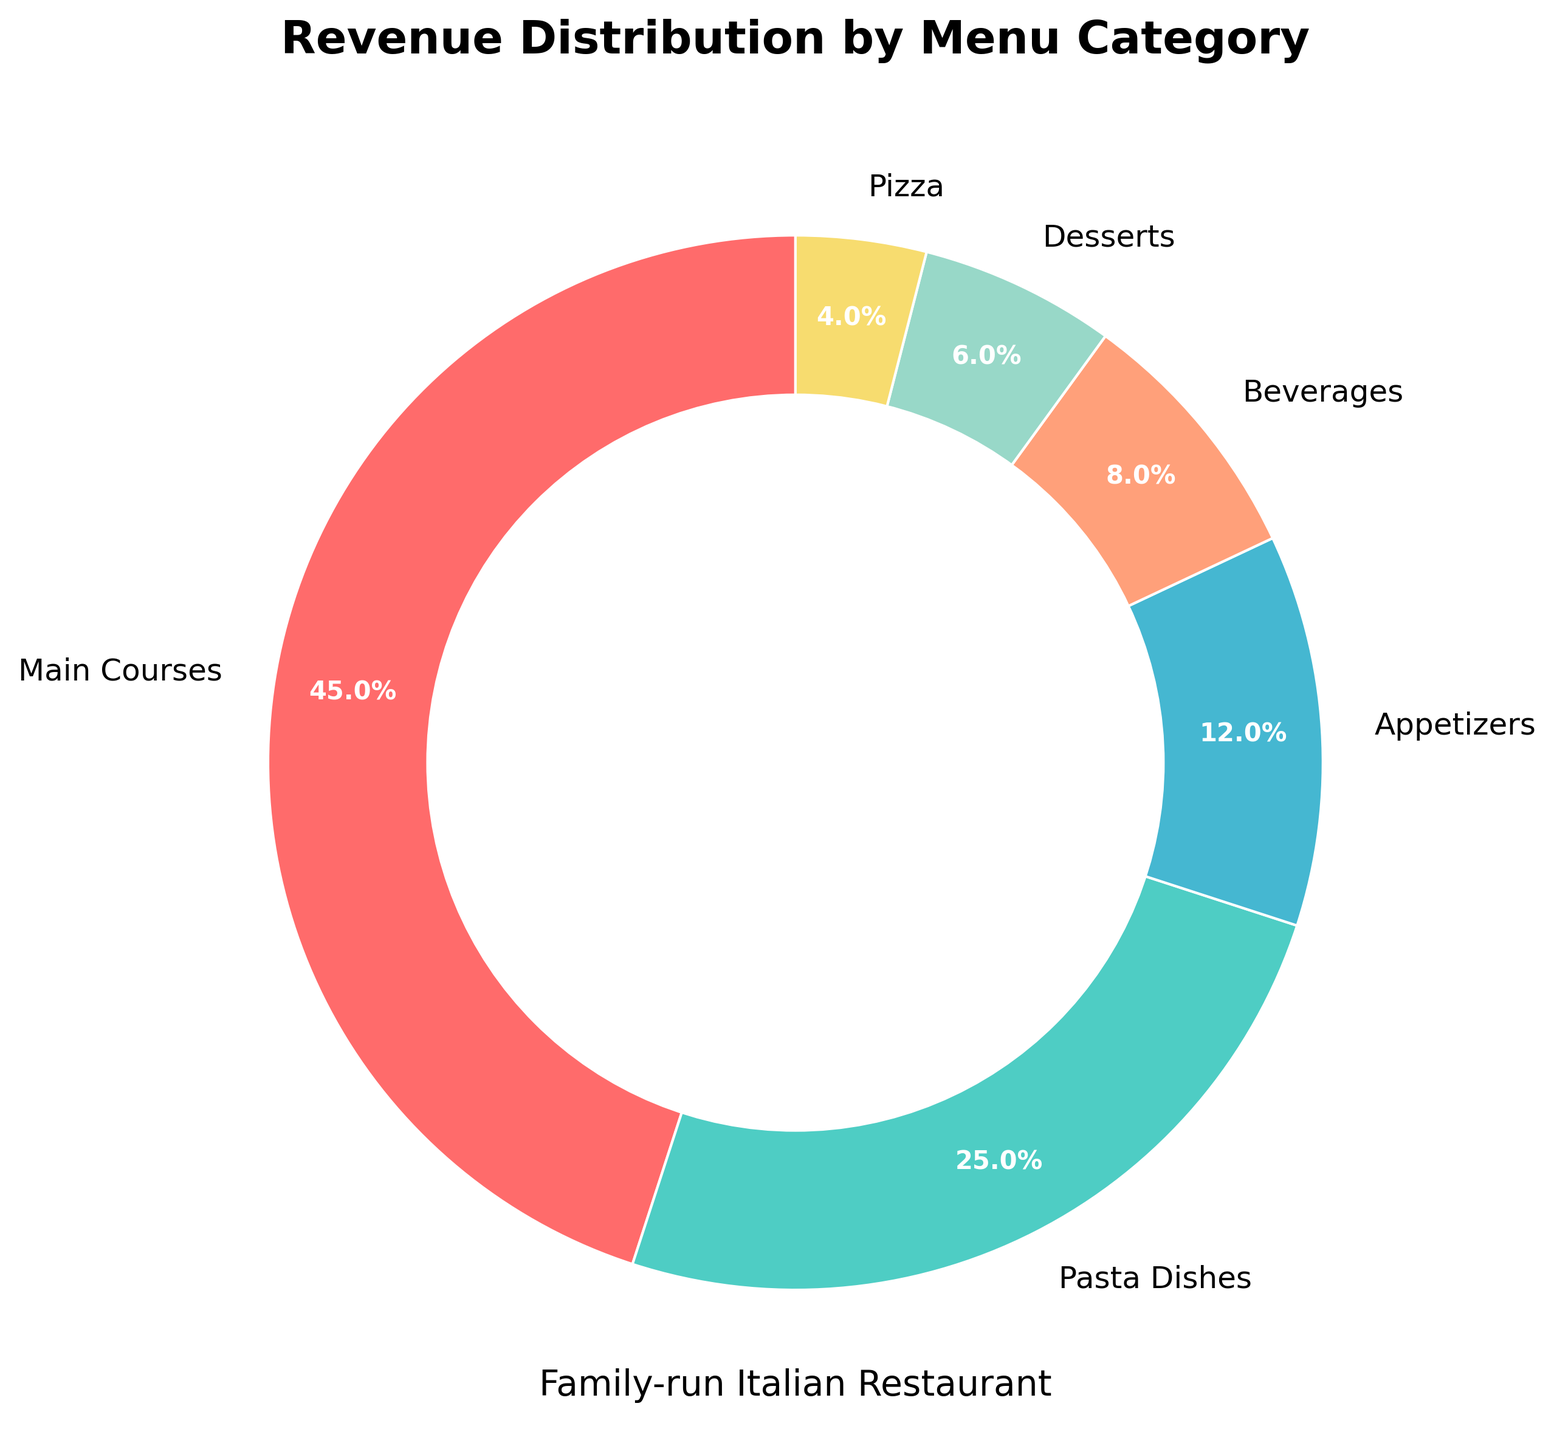Which category contributes the most to the restaurant's revenue? The largest slice in the pie chart represents the "Main Courses" category at 45%, which is the highest percentage.
Answer: Main Courses Which two categories contribute the least to the restaurant's revenue? The smallest slices in the pie chart represent "Pizza" and "Desserts" at 4% and 6%, respectively, making them the categories with the least contribution.
Answer: Pizza and Desserts What is the combined revenue percentage for Pasta Dishes and Beverages? To find the combined percentage, sum up the values for Pasta Dishes (25%) and Beverages (8%): 25% + 8% = 33%.
Answer: 33% Is the revenue from Main Courses more than double the revenue from Desserts? The percentage for Main Courses is 45% and for Desserts is 6%. Calculating double of Desserts gives 6% * 2 = 12%, which is indeed less than 45%.
Answer: Yes What color represents the Appetizers category? The color corresponding to the "Appetizers" label on the pie chart is matched to a specific visual slice, which is a bluish-green shade.
Answer: Bluish-green Is the sum of the revenue percentages of Appetizers and Desserts greater than the revenue from Pasta Dishes? Summing up the percentages for Appetizers (12%) and Desserts (6%) gives 12% + 6% = 18%, which is less than the 25% for Pasta Dishes.
Answer: No How much is the revenue difference between the categories of Beverages and Pizza? Subtracting the percentage for Pizza from the percentage for Beverages: 8% - 4% gives us the difference.
Answer: 4% Are there more categories contributing less than 10% each or more than 10% each? By observing the chart, count the categories with less than 10%: Beverages (8%), Desserts (6%), and Pizza (4%) — 3 categories. Count the more-than-10% categories: Main Courses (45%), Pasta Dishes (25%), Appetizers (12%) — 3 categories.
Answer: Equal What is the second largest revenue category? The pie chart shows that the second largest slice after Main Courses (45%) is for Pasta Dishes (25%).
Answer: Pasta Dishes Compare the percentage contribution of Beverages and Desserts visually and state which is larger. The pie chart slice for Beverages is larger than that for Desserts, with 8% compared to 6%.
Answer: Beverages 